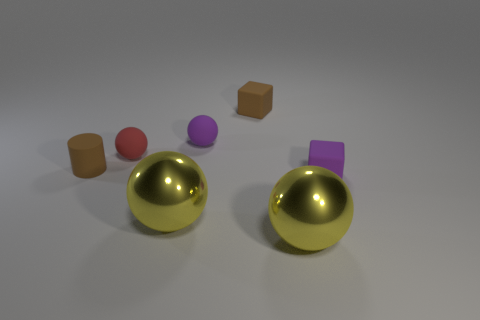What number of other objects are there of the same shape as the red matte thing?
Ensure brevity in your answer.  3. Does the cylinder have the same color as the small cube behind the red sphere?
Provide a succinct answer. Yes. There is a tiny purple thing that is left of the tiny rubber block behind the purple matte block; what is its shape?
Provide a succinct answer. Sphere. Does the purple matte thing behind the tiny rubber cylinder have the same shape as the small red matte thing?
Keep it short and to the point. Yes. Are there more large metallic things on the right side of the tiny purple rubber sphere than rubber cylinders to the left of the rubber cylinder?
Your response must be concise. Yes. How many brown cylinders are left of the block behind the tiny purple rubber cube?
Give a very brief answer. 1. What number of other objects are there of the same color as the rubber cylinder?
Offer a very short reply. 1. The block that is to the left of the purple block in front of the cylinder is what color?
Make the answer very short. Brown. Are there any rubber objects that have the same color as the cylinder?
Provide a succinct answer. Yes. What number of metal objects are either big balls or tiny things?
Provide a succinct answer. 2. 